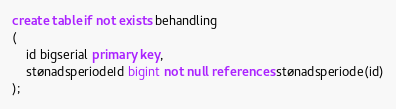Convert code to text. <code><loc_0><loc_0><loc_500><loc_500><_SQL_>create table if not exists behandling
(
    id bigserial primary key,
    stønadsperiodeId bigint not null references stønadsperiode(id)
);</code> 